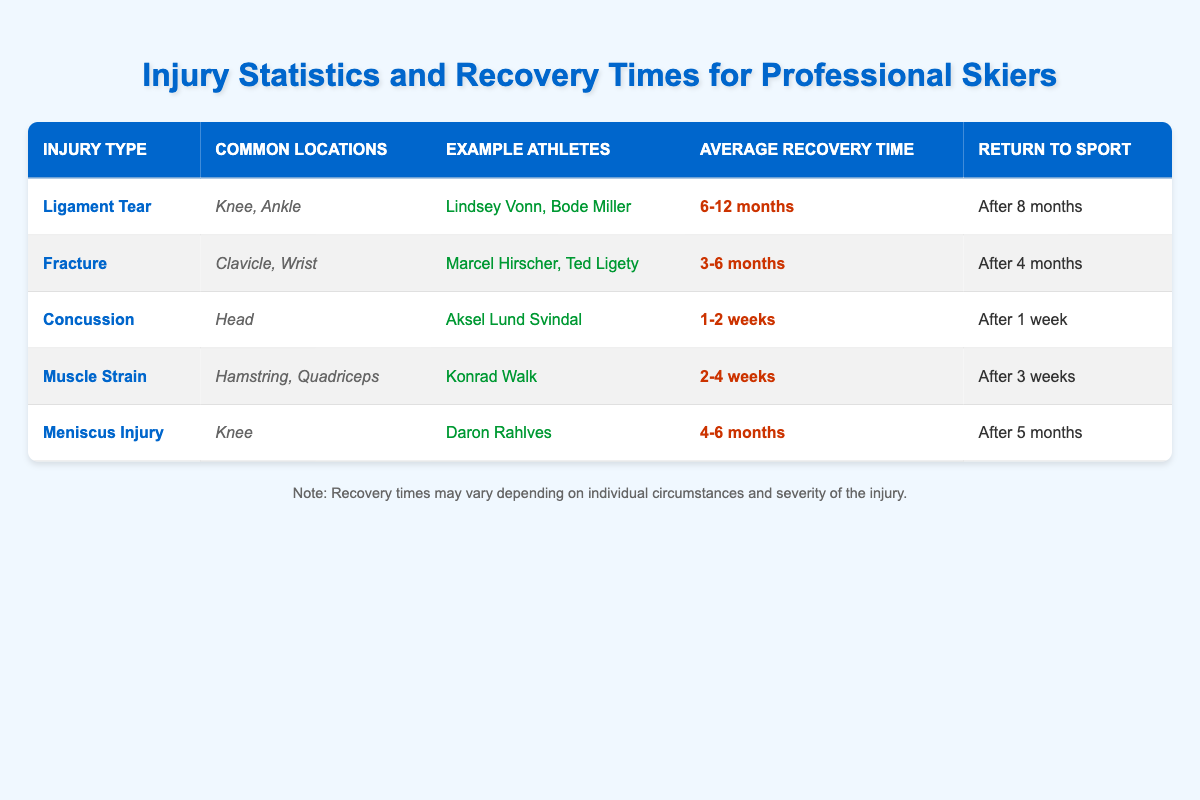What is the average recovery time for a ligament tear? From the table, the recovery time for a ligament tear is listed as 6-12 months. This is stated clearly in the "Average Recovery Time" column under the "Ligament Tear" row.
Answer: 6-12 months Which athletes are associated with muscle strains? The table lists Konrad Walk as the example athlete for muscle strains under the "Example Athletes" column in the respective row. Thus, only Konrad Walk is mentioned in this context.
Answer: Konrad Walk Is it true that concussions have a longer recovery time than fractures? By examining the recovery times listed, concussions have an average recovery time of 1-2 weeks while fractures have 3-6 months. Since 3-6 months is significantly longer than 1-2 weeks, this statement is false.
Answer: No How many different injury types are mentioned? The table contains five distinct injury types: Ligament Tear, Fracture, Concussion, Muscle Strain, and Meniscus Injury. This can be counted by observing the entries under the "Injury Type" column.
Answer: 5 What is the difference in average recovery time between fractures and meniscus injuries? The average recovery time for fractures is 3-6 months, and for meniscus injuries, it is 4-6 months. To find the difference, we consider the upper values (6 months - 4 months = 2 months), which indicates a potential difference of 2 months in recovery time in favor of fractures.
Answer: 2 months Who are the athletes that have experienced ligament tears? According to the "Example Athletes" column under the "Ligament Tear" injury type, Lindsey Vonn and Bode Miller are identified as athletes who have experienced this type of injury.
Answer: Lindsey Vonn, Bode Miller What is the average recovery time for all injuries listed? The average recovery times are as follows: Ligament Tear (6-12 months), Fracture (3-6 months), Concussion (1-2 weeks), Muscle Strain (2-4 weeks), and Meniscus Injury (4-6 months). We convert these to months for easier calculation: Ligament Tear (9 months), Fracture (4.5 months), Concussion (0.5 months), Muscle Strain (0.75 months), Meniscus Injury (5 months). Summing these values gives 9 + 4.5 + 0.5 + 0.75 + 5 = 20.75 months. There are five injuries, hence average recovery time = 20.75 months / 5 = 4.15 months, or about 4 months.
Answer: About 4 months Which injury has the shortest recovery time? The recovery times are compared: Ligament Tear (6-12 months), Fracture (3-6 months), Concussion (1-2 weeks), Muscle Strain (2-4 weeks), Meniscus Injury (4-6 months). Since 1-2 weeks corresponds to the shortest time frame, the concussion has the shortest recovery time.
Answer: Concussion What is the common location for muscle strains? From the "Common Locations" column under the "Muscle Strain" row, the locations listed are Hamstring and Quadriceps. Therefore, these are the common locations identified for this type of injury.
Answer: Hamstring, Quadriceps 